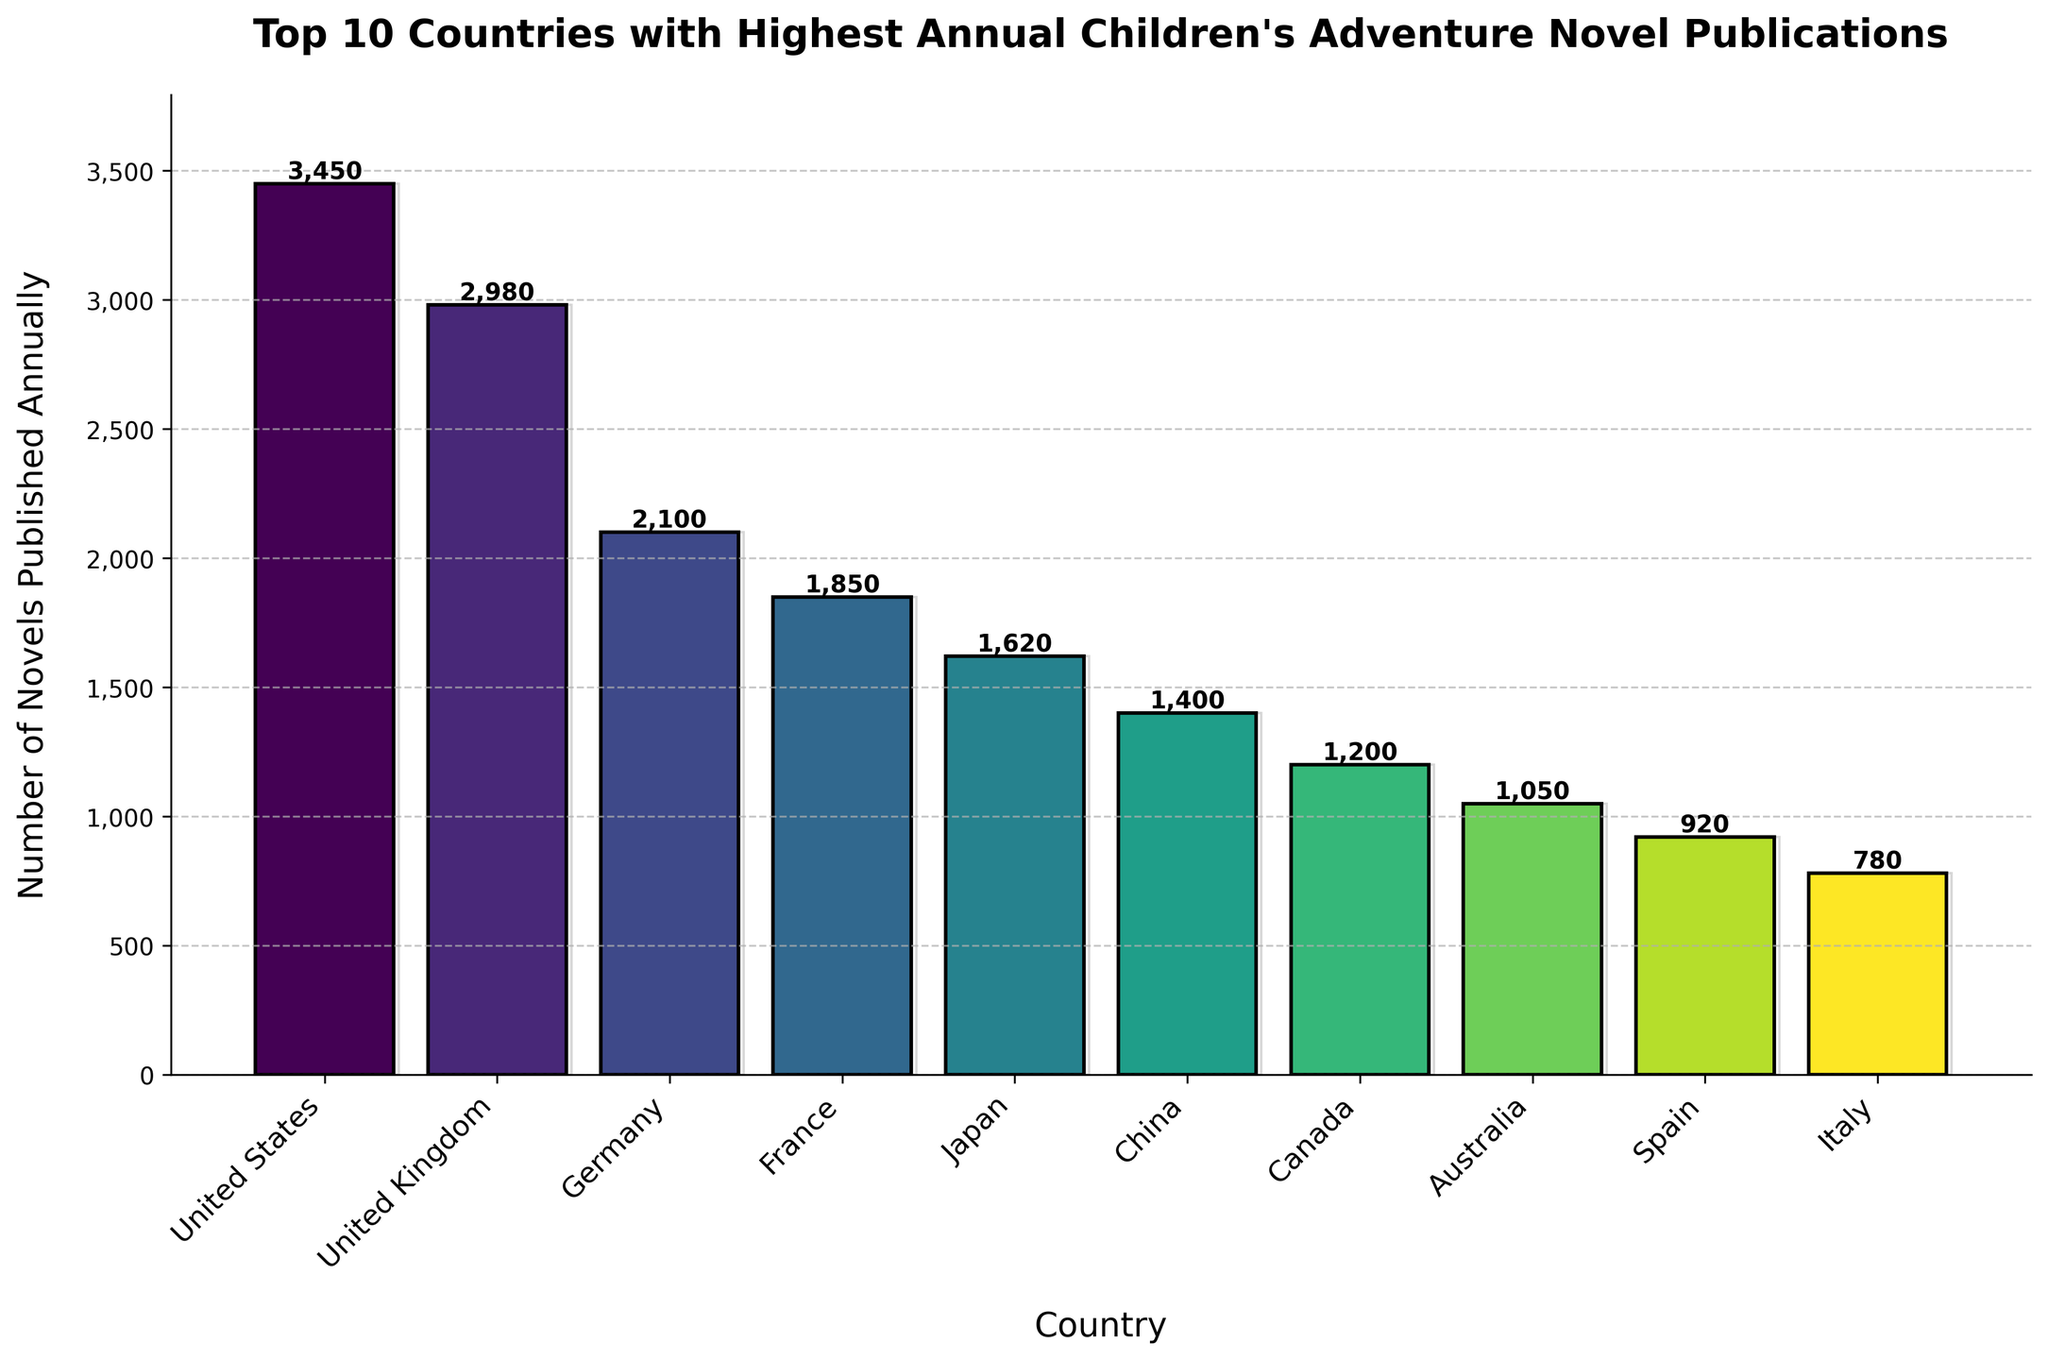What is the total number of children's adventure novels published annually by the top 3 countries? The United States publishes 3450 novels, the United Kingdom publishes 2980 novels, and Germany publishes 2100 novels annually. Adding these figures gives: 3450 + 2980 + 2100 = 8530
Answer: 8530 Which country in the top 10 publishes the fewest children's adventure novels annually? According to the bar chart, Italy publishes the fewest with 780 novels annually.
Answer: Italy How many more novels are published by the United States compared to Japan annually? The United States publishes 3450 novels and Japan publishes 1620 novels. The difference is 3450 - 1620 = 1830
Answer: 1830 What is the average number of children's adventure novels published annually by the top 5 countries? The top 5 countries are the United States, the United Kingdom, Germany, France, and Japan. Their publication numbers are 3450, 2980, 2100, 1850, and 1620, respectively. The sum is 3450 + 2980 + 2100 + 1850 + 1620 = 12000. Average is 12000 / 5 = 2400
Answer: 2400 Arrange the top 10 countries in decreasing order of the number of children's adventure novels published annually. The countries ranked from highest to lowest are: United States, United Kingdom, Germany, France, Japan, China, Canada, Australia, Spain, and Italy.
Answer: United States, United Kingdom, Germany, France, Japan, China, Canada, Australia, Spain, Italy Which country has nearly half the number of novels published annually compared to the United Kingdom? The United Kingdom publishes 2980 novels. The country publishing nearly half would have around 1490 novels. China publishes 1400 novels, which is closest to half the UK's count.
Answer: China Which bars on the chart are approximately half the height of the bar representing the United States? The United States bar is 3450 units high. Bars representing around 1725 would be approximately half. Germany (2100) and France (1850) are bars closer to half the height of the United States bar.
Answer: Germany, France How many countries publish more children's adventure novels annually than Australia? Australia publishes 1050 novels. The countries that publish more than 1050 novels are the United States, United Kingdom, Germany, France, Japan, China, and Canada, totaling 7 countries.
Answer: 7 